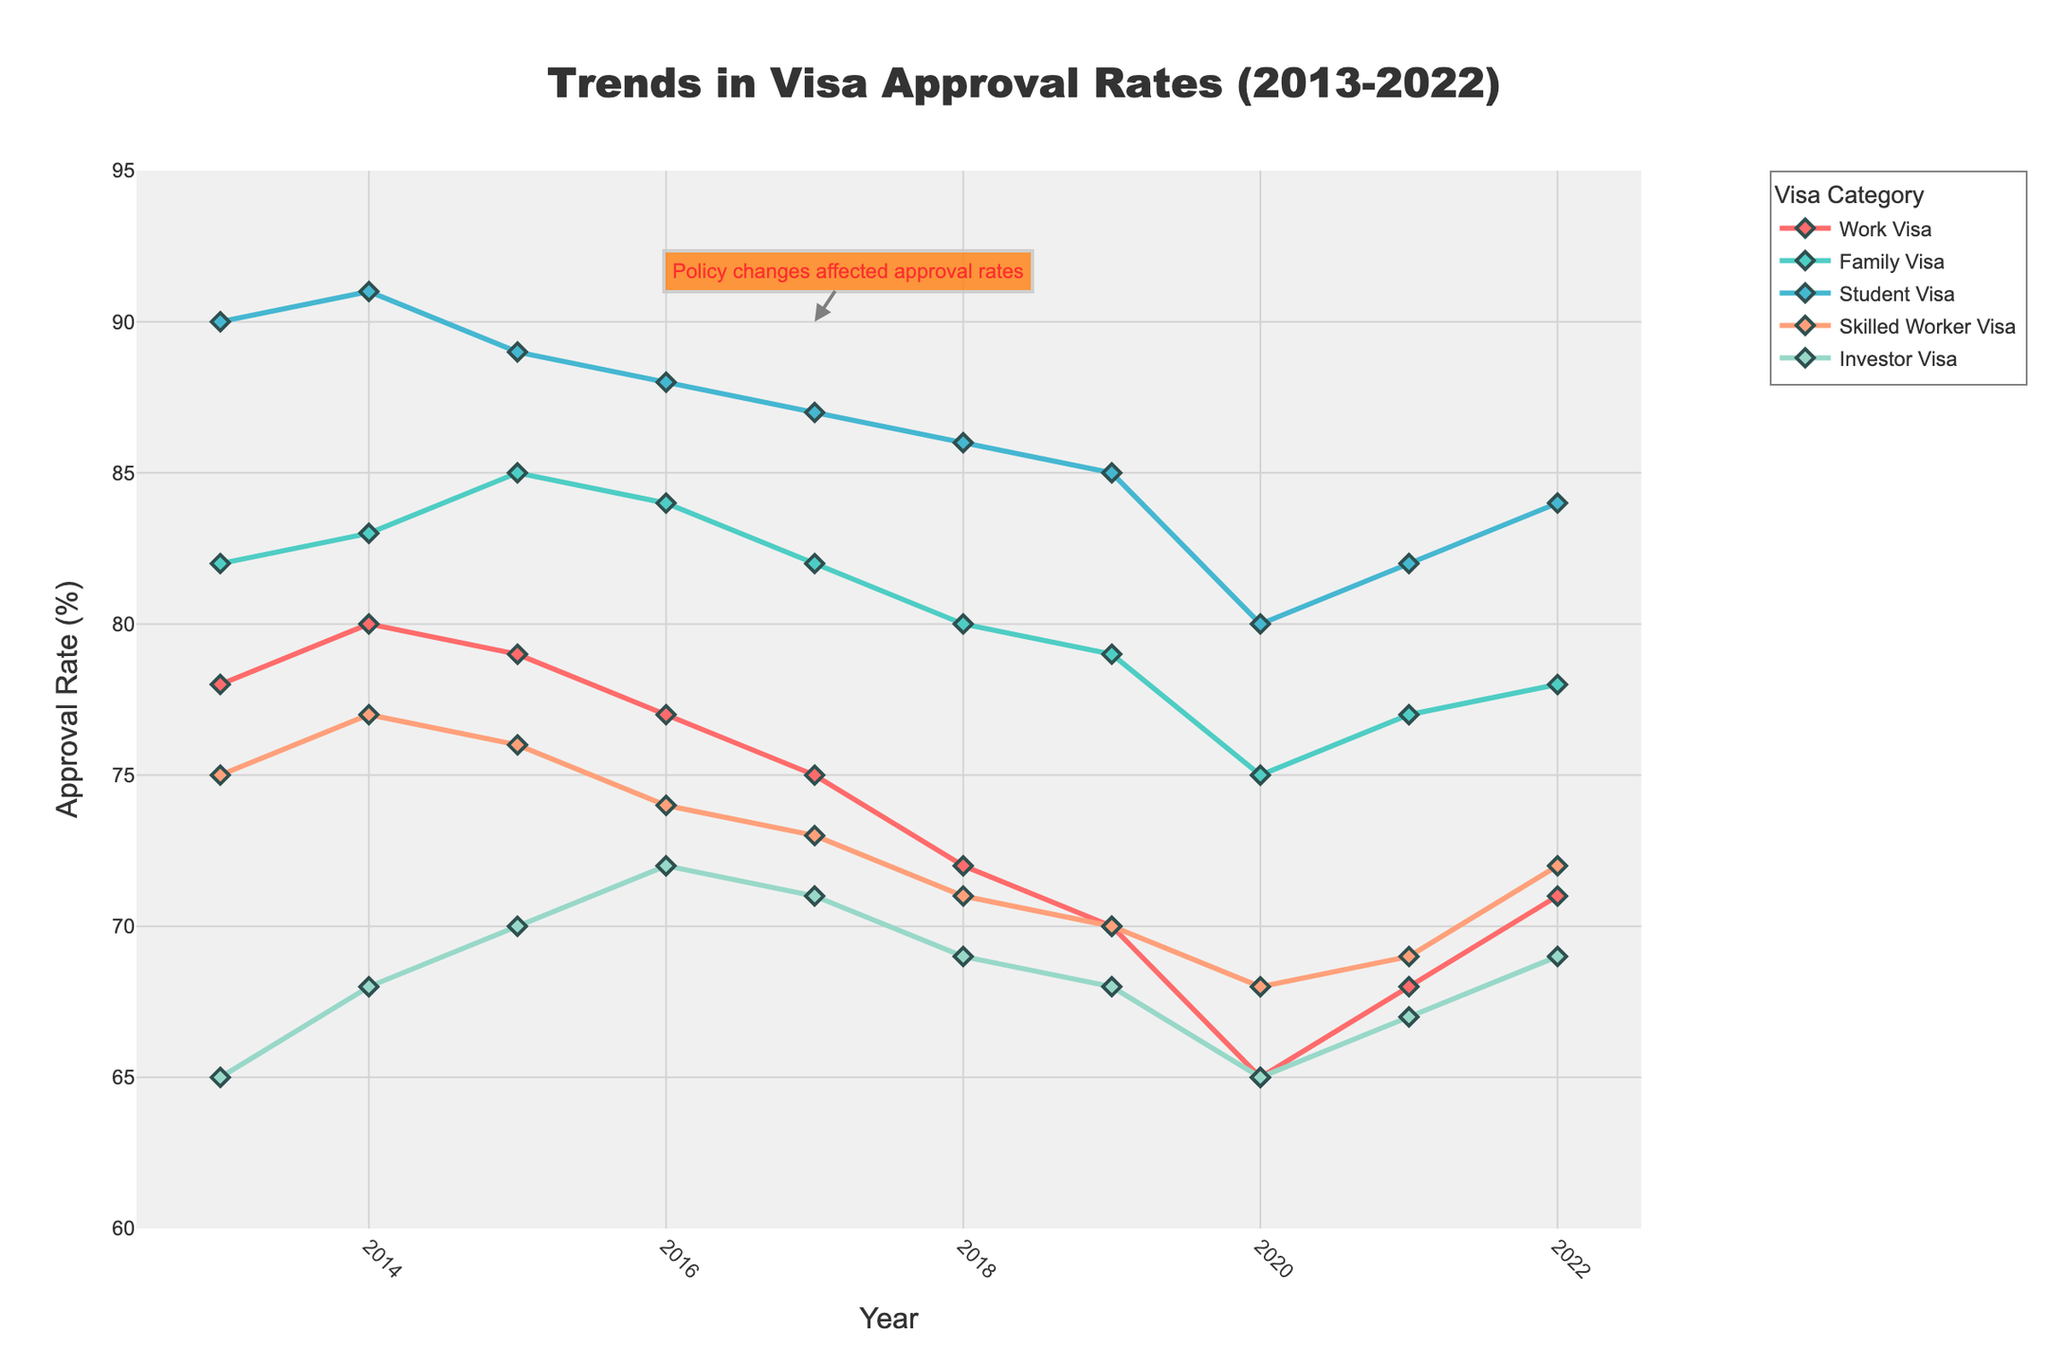What's the overall trend for the Work Visa approval rate from 2013 to 2022? The Work Visa approval rate starts at 78% in 2013, peaks at 80% in 2014, and declines to a low of 65% in 2020. It slightly recovers to 71% by 2022.
Answer: Decreasing Which visa category had the highest approval rate in 2022? In 2022, the Student Visa had the highest approval rate, visually indicated by its position at the top of the graph for this year.
Answer: Student Visa What is the difference between the highest and lowest approval rates for the Skilled Worker Visa over the decade? The highest approval rate for the Skilled Worker Visa is 77% in 2014, and the lowest is 68% in 2020. The difference is 77 - 68 = 9%.
Answer: 9% How does the Investor Visa approval rate in 2017 compare to that in 2022? In 2017, the approval rate for the Investor Visa was 71%, while in 2022, it was 69%. This is visually confirmed by the plot, showing a slight decline.
Answer: Lower Which two visa categories had the closest approval rates in 2020? In 2020, the Work Visa and Investor Visa had approval rates of 65%. This is visible in the plot as these two lines converge at this point.
Answer: Work Visa and Investor Visa What was the average approval rate for the Family Visa from 2018 to 2020? The Family Visa had approval rates of 80%, 79%, and 75% from 2018 to 2020. The average is (80 + 79 + 75) / 3 = 234 / 3 = 78%.
Answer: 78% In which year did the Work Visa category experience the most significant drop in approval rates? The most significant drop is between 2019 (70%) and 2020 (65%), a fall of 5%. This is the steepest decline visible on the chart for the Work Visa line.
Answer: 2020 What is the overall trend in the Student Visa approval rate over the past decade? The Student Visa approval rate declines slightly from 90% in 2013 to 85% in 2019, hits a low of 80% in 2020, and then partially recovers to 84% by 2022.
Answer: Decreasing Compare the approval rates of Work Visa and Skilled Worker Visa in 2021. Which one is higher? In 2021, the Work Visa approval rate is 68% and the Skilled Worker Visa is 69%. Thus, the Skilled Worker Visa has a higher approval rate.
Answer: Skilled Worker Visa 